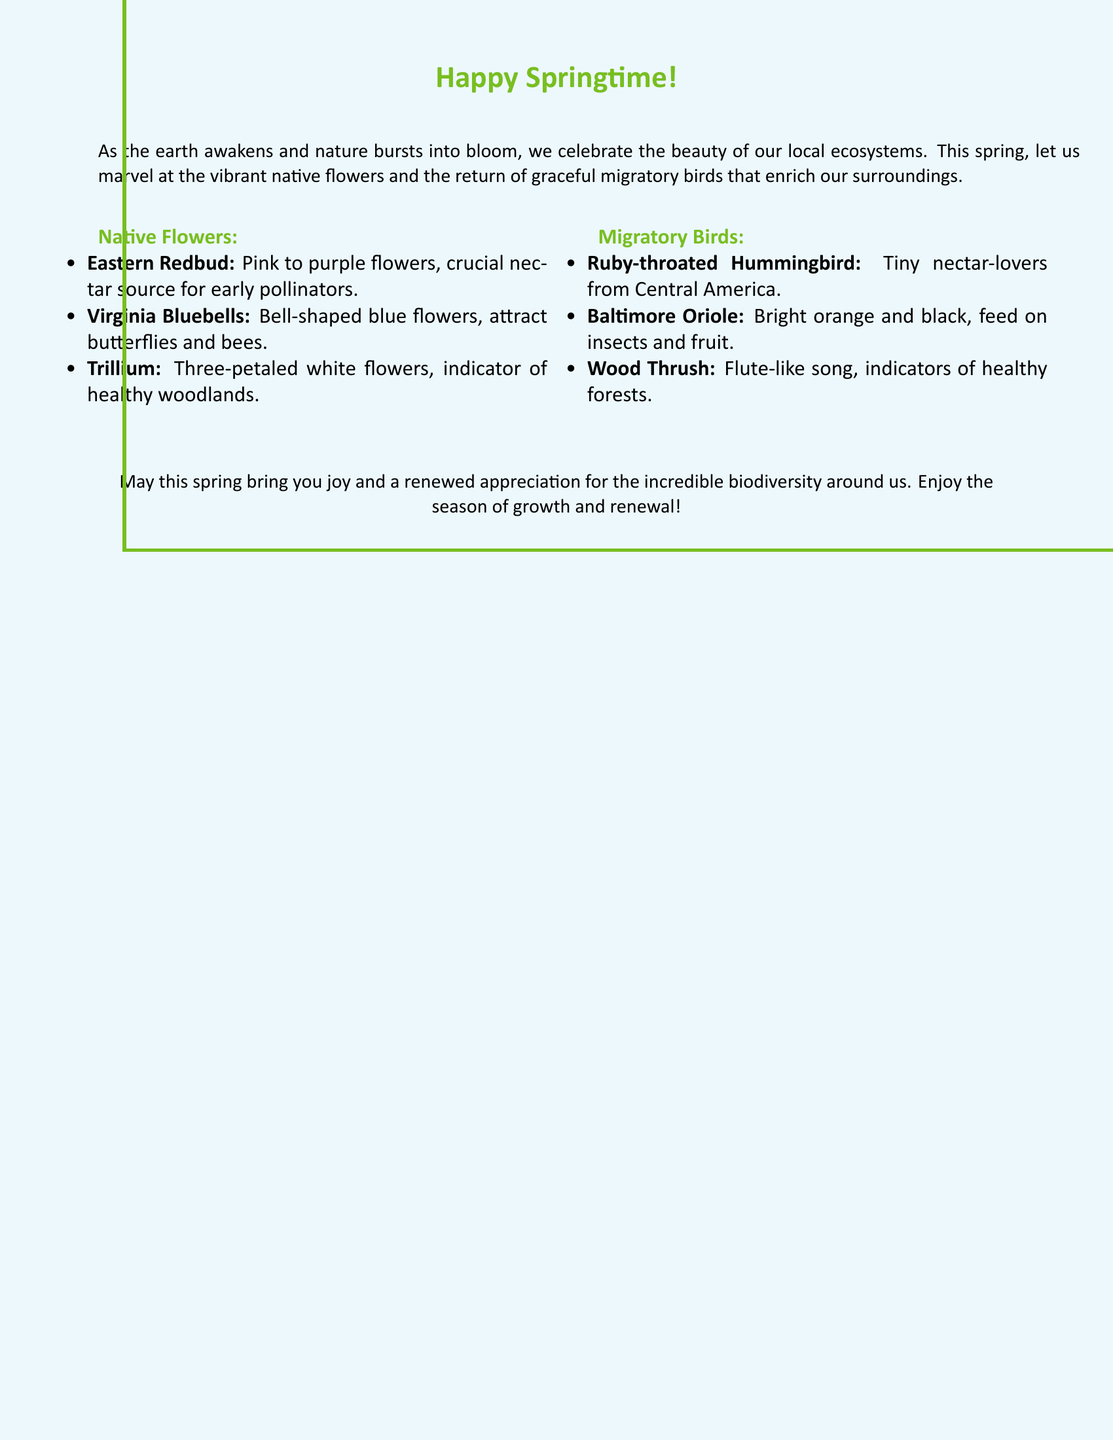What is the theme of the greeting card? The theme celebrates the arrival of spring and the beauty of local ecosystems, focusing on native flowers and migratory birds.
Answer: Springtime Name one native flower mentioned in the card. The card lists several native flowers, including the Eastern Redbud.
Answer: Eastern Redbud What color are the Virginia Bluebells? The card describes the color of the Virginia Bluebells as blue.
Answer: Blue Which migratory bird is known for its vibrant orange and black colors? The card mentions the Baltimore Oriole, which has bright orange and black plumage.
Answer: Baltimore Oriole What type of flower is Trillium described as? The card notes that Trillium has three-petaled white flowers.
Answer: Three-petaled white How does the Ruby-throated Hummingbird obtain its food? The card states that Ruby-throated Hummingbirds are tiny nectar-lovers.
Answer: Nectar What does the song of the Wood Thrush signify? The card indicates that the song of the Wood Thrush is an indicator of healthy forests.
Answer: Healthy forests Why are native flowers important according to the card? The document mentions that native flowers are crucial nectar sources for pollinators.
Answer: Nectar sources What does spring symbolize in the card? The card highlights spring as a season of growth and renewal.
Answer: Growth and renewal 